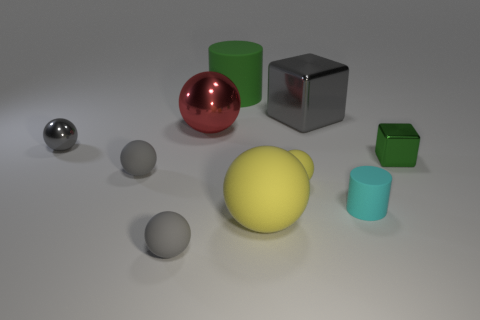What number of objects are rubber things behind the big metal cube or blocks in front of the large red sphere?
Offer a terse response. 2. Does the red thing have the same material as the cylinder behind the big cube?
Your answer should be very brief. No. What is the shape of the thing that is both behind the big red thing and to the right of the small yellow matte object?
Provide a short and direct response. Cube. How many other things are the same color as the large matte sphere?
Keep it short and to the point. 1. What is the shape of the red object?
Make the answer very short. Sphere. There is a sphere in front of the yellow sphere that is in front of the cyan matte object; what color is it?
Your response must be concise. Gray. Is the color of the small shiny block the same as the small ball that is in front of the cyan rubber thing?
Keep it short and to the point. No. There is a object that is in front of the green metal cube and to the right of the big block; what material is it made of?
Give a very brief answer. Rubber. Is there a gray object that has the same size as the gray shiny sphere?
Your response must be concise. Yes. There is a cube that is the same size as the cyan rubber thing; what is it made of?
Provide a short and direct response. Metal. 